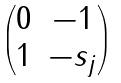<formula> <loc_0><loc_0><loc_500><loc_500>\begin{pmatrix} 0 & - 1 \\ 1 & - s _ { j } \end{pmatrix}</formula> 